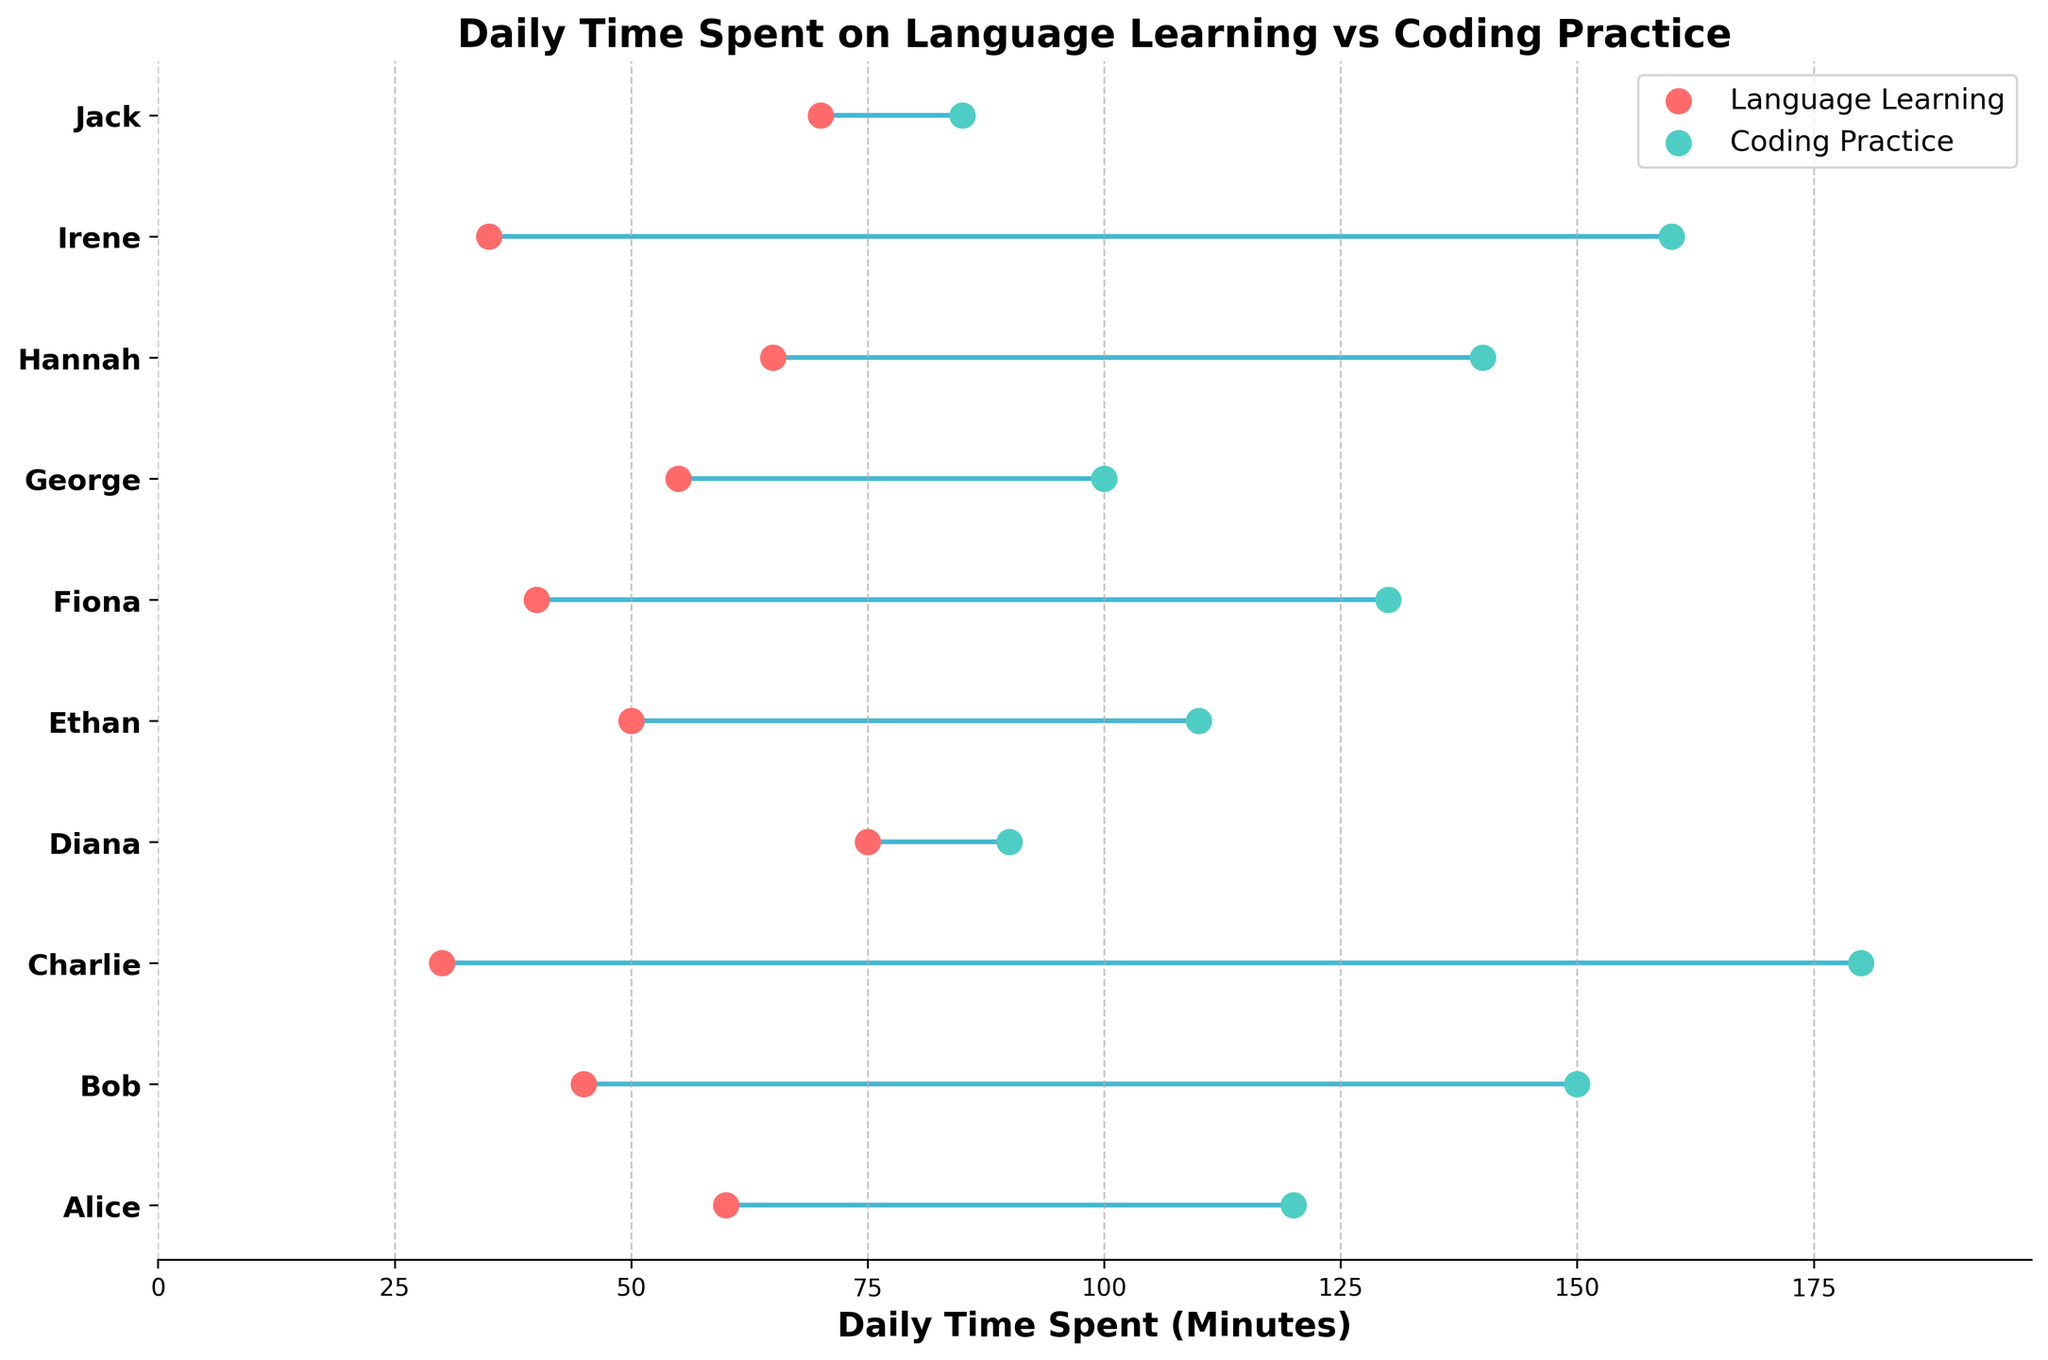What is the title of the plot? The title is usually placed at the top of the plot. Here, it is centered and in bold, which makes it easy to read.
Answer: Daily Time Spent on Language Learning vs Coding Practice How many individuals are represented in the plot? Each individual is listed along the y-axis with their name. By counting them, we get the total number of individuals.
Answer: 10 Which individual spends the most time on coding practice? By observing the x-axis values for coding practice (green dots), the farthest right value represents the individual with the most time. Charlie's green dot is the farthest right at 180 minutes.
Answer: Charlie Who spends more time on language learning: George or Irene? By comparing the positions of the red dots representing George and Irene, we see that George's red dot is further to the right (55 minutes) compared to Irene's (35 minutes).
Answer: George What are the colors representing language learning and coding practice respectively? The plot's legend indicates the colors, with language learning represented by red and coding practice by green.
Answer: Red and Green Which individual has the smallest difference between time spent on language learning and coding practice? By comparing the lengths of the lines connecting the red and green dots for each individual, the shortest line represents the smallest difference. Jack has the shortest line (70 and 85 minutes respectively, difference of 15 minutes).
Answer: Jack What is the average daily time spent on language learning by all individuals? To find the mean, sum all the individual daily time spent on language learning and divide by the number of individuals: (60+45+30+75+50+40+55+65+35+70)/10. The total is 525, so the average is 525/10.
Answer: 52.5 minutes Which individual spends more time on language learning compared to coding practice? By viewing the plot, the individual whose red dot is positioned to the right of their green dot spends more time on language learning. Diana's red dot (75 minutes) is further right than her green dot (90 minutes), suggesting more time on language learning.
Answer: Diana 